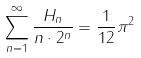<formula> <loc_0><loc_0><loc_500><loc_500>\sum _ { n = 1 } ^ { \infty } \frac { H _ { n } } { n \cdot 2 ^ { n } } = \frac { 1 } { 1 2 } \pi ^ { 2 }</formula> 